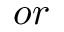<formula> <loc_0><loc_0><loc_500><loc_500>o r</formula> 